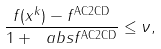<formula> <loc_0><loc_0><loc_500><loc_500>\frac { f ( x ^ { k } ) - f ^ { \text {AC2CD} } } { 1 + \ a b s { f ^ { \text {AC2CD} } } } \leq \nu ,</formula> 